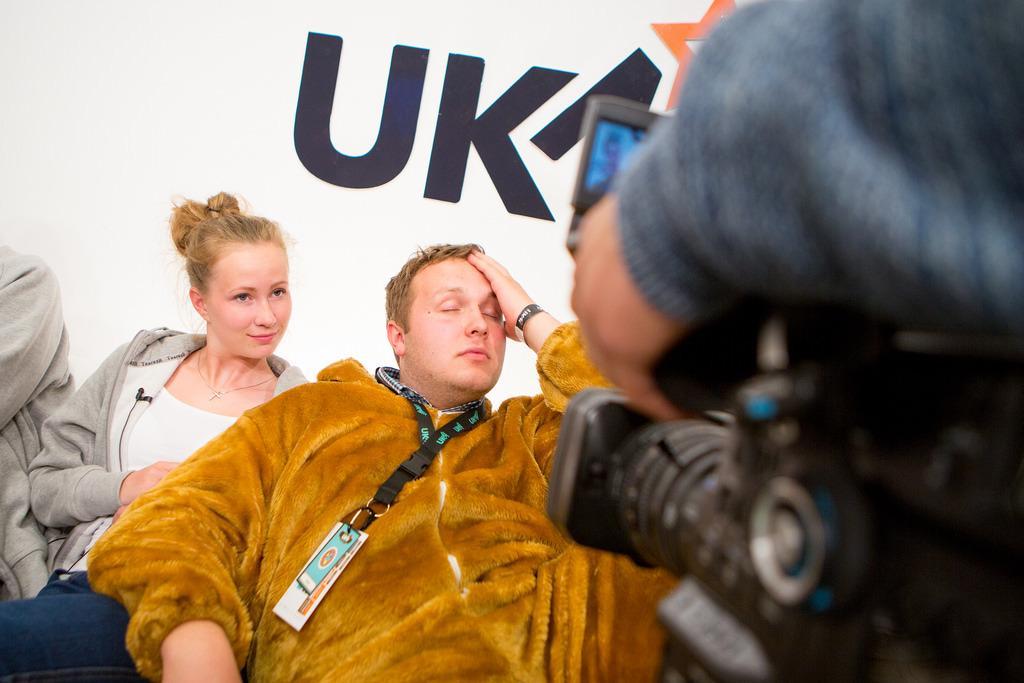How would you summarize this image in a sentence or two? In this image there are some people who are sitting, in the foreground there is one man who is holding the camera and in the background there is some text. 